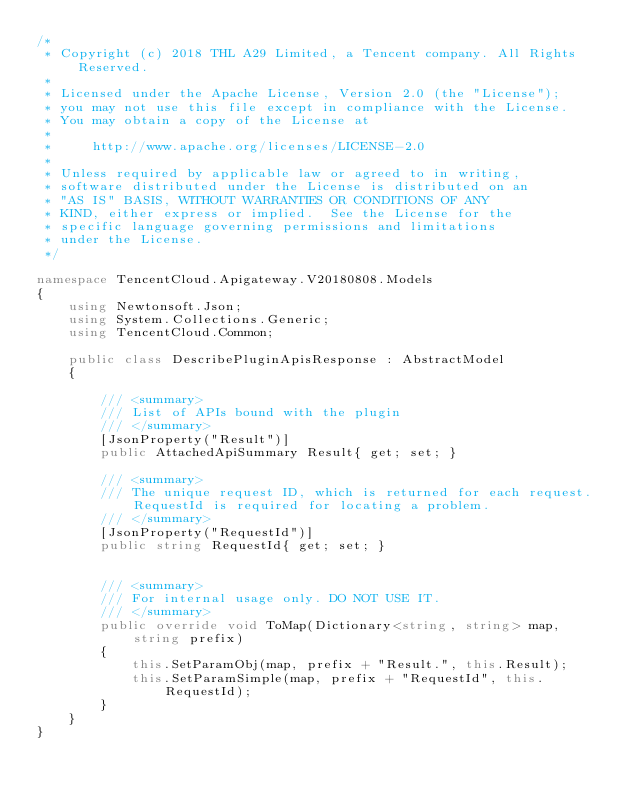Convert code to text. <code><loc_0><loc_0><loc_500><loc_500><_C#_>/*
 * Copyright (c) 2018 THL A29 Limited, a Tencent company. All Rights Reserved.
 *
 * Licensed under the Apache License, Version 2.0 (the "License");
 * you may not use this file except in compliance with the License.
 * You may obtain a copy of the License at
 *
 *     http://www.apache.org/licenses/LICENSE-2.0
 *
 * Unless required by applicable law or agreed to in writing,
 * software distributed under the License is distributed on an
 * "AS IS" BASIS, WITHOUT WARRANTIES OR CONDITIONS OF ANY
 * KIND, either express or implied.  See the License for the
 * specific language governing permissions and limitations
 * under the License.
 */

namespace TencentCloud.Apigateway.V20180808.Models
{
    using Newtonsoft.Json;
    using System.Collections.Generic;
    using TencentCloud.Common;

    public class DescribePluginApisResponse : AbstractModel
    {
        
        /// <summary>
        /// List of APIs bound with the plugin
        /// </summary>
        [JsonProperty("Result")]
        public AttachedApiSummary Result{ get; set; }

        /// <summary>
        /// The unique request ID, which is returned for each request. RequestId is required for locating a problem.
        /// </summary>
        [JsonProperty("RequestId")]
        public string RequestId{ get; set; }


        /// <summary>
        /// For internal usage only. DO NOT USE IT.
        /// </summary>
        public override void ToMap(Dictionary<string, string> map, string prefix)
        {
            this.SetParamObj(map, prefix + "Result.", this.Result);
            this.SetParamSimple(map, prefix + "RequestId", this.RequestId);
        }
    }
}

</code> 